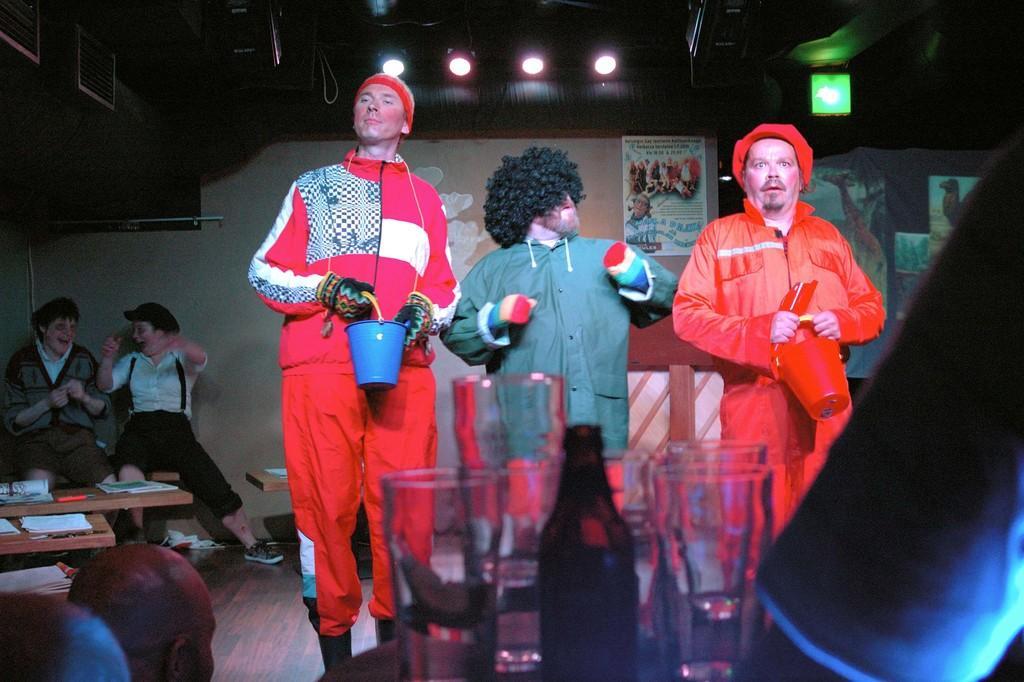Can you describe this image briefly? In the image there are three men in joker costume standing in the middle, in the front there are wine bottles and glasses on the table, on the left side there are few persons sitting on chairs laughing and there are lights over the ceiling. 